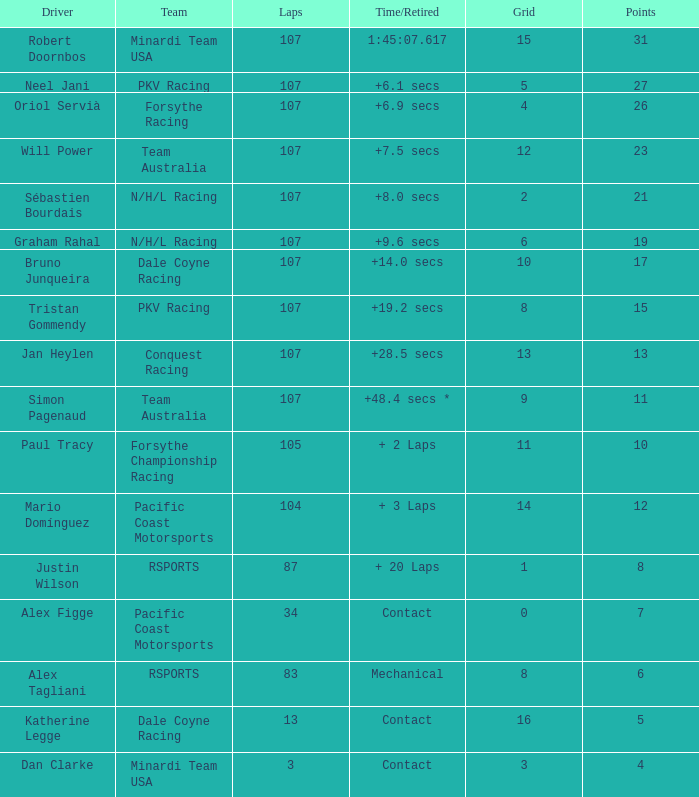What is mario domínguez's mean grid placement? 14.0. 